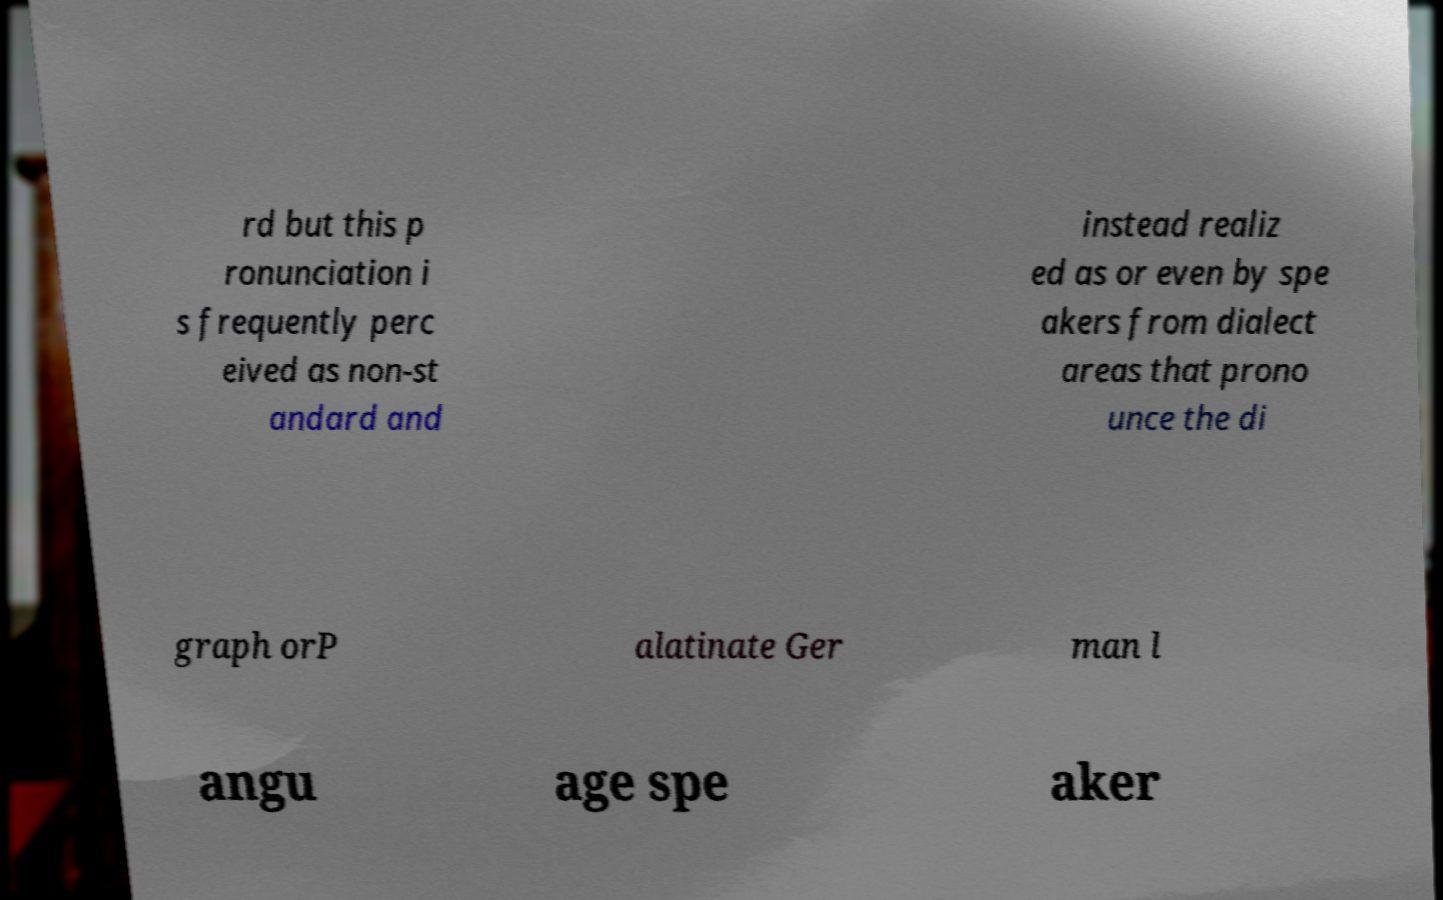Please read and relay the text visible in this image. What does it say? rd but this p ronunciation i s frequently perc eived as non-st andard and instead realiz ed as or even by spe akers from dialect areas that prono unce the di graph orP alatinate Ger man l angu age spe aker 